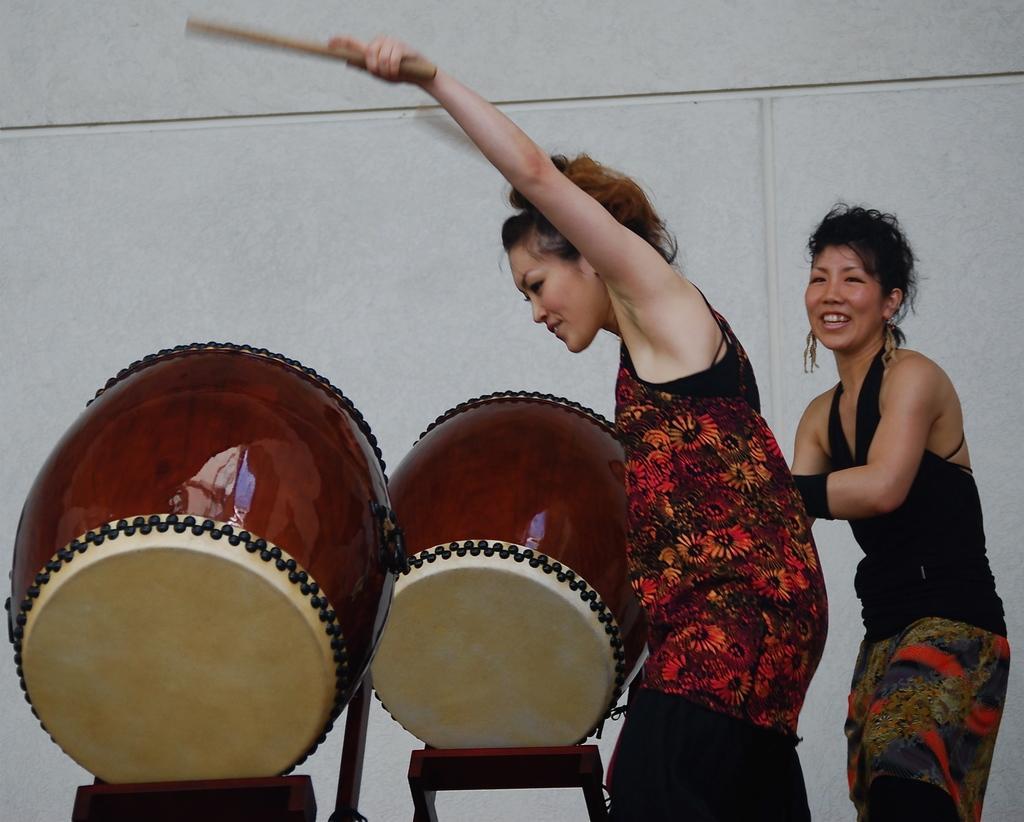Please provide a concise description of this image. In this image there are two ladies. One lady is holding a stick. There are musical instruments. In the back there is a wall. 